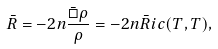<formula> <loc_0><loc_0><loc_500><loc_500>\bar { R } = - 2 n \frac { \bar { \Box } \rho } { \rho } = - 2 n \bar { R } i c ( T , T ) ,</formula> 